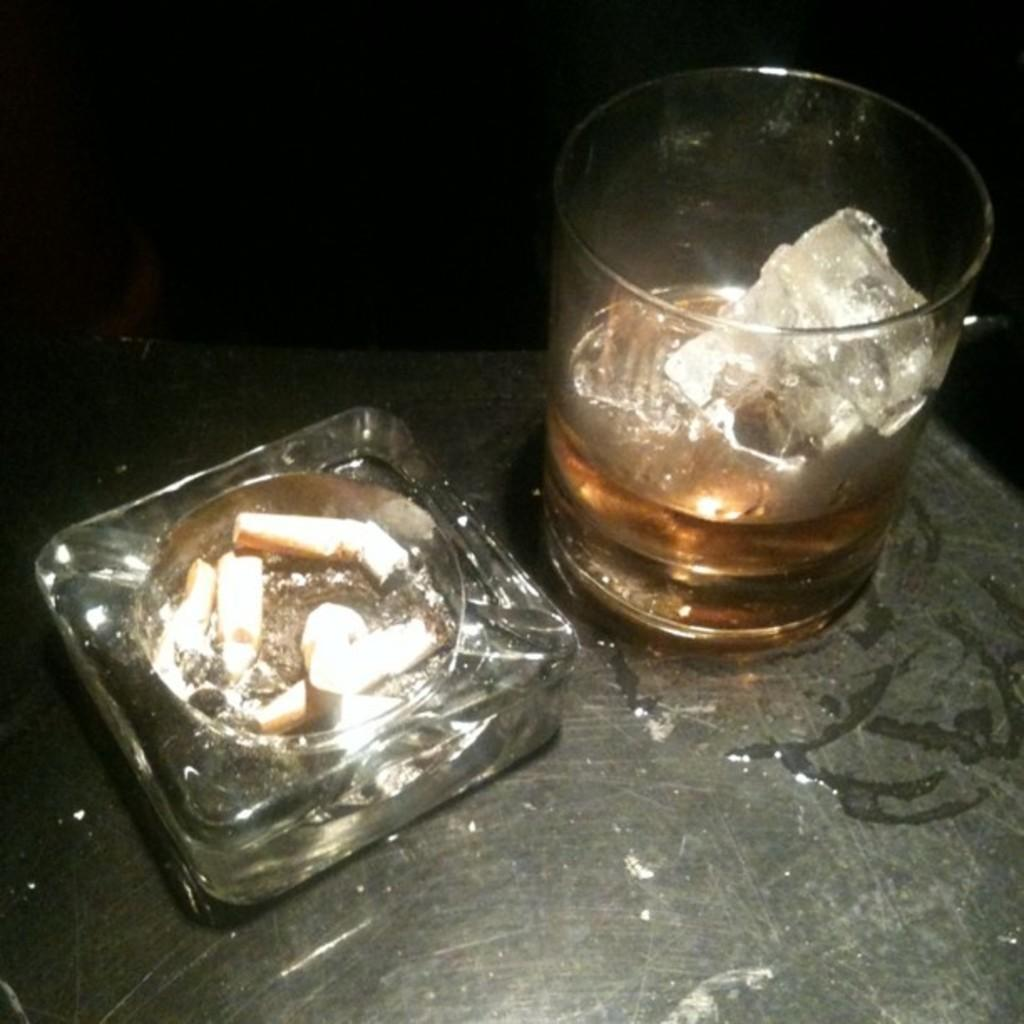What piece of furniture is present in the image? There is a table in the image. What can be found on the table? There is a glass with a drink and an ice cube on the table. What is located on the left side of the table? There is a bowl with cigars on the left side of the table. What type of tin can be seen smashing the glass in the image? There is no tin or smashing action present in the image. The glass with a drink and an ice cube is simply sitting on the table. 